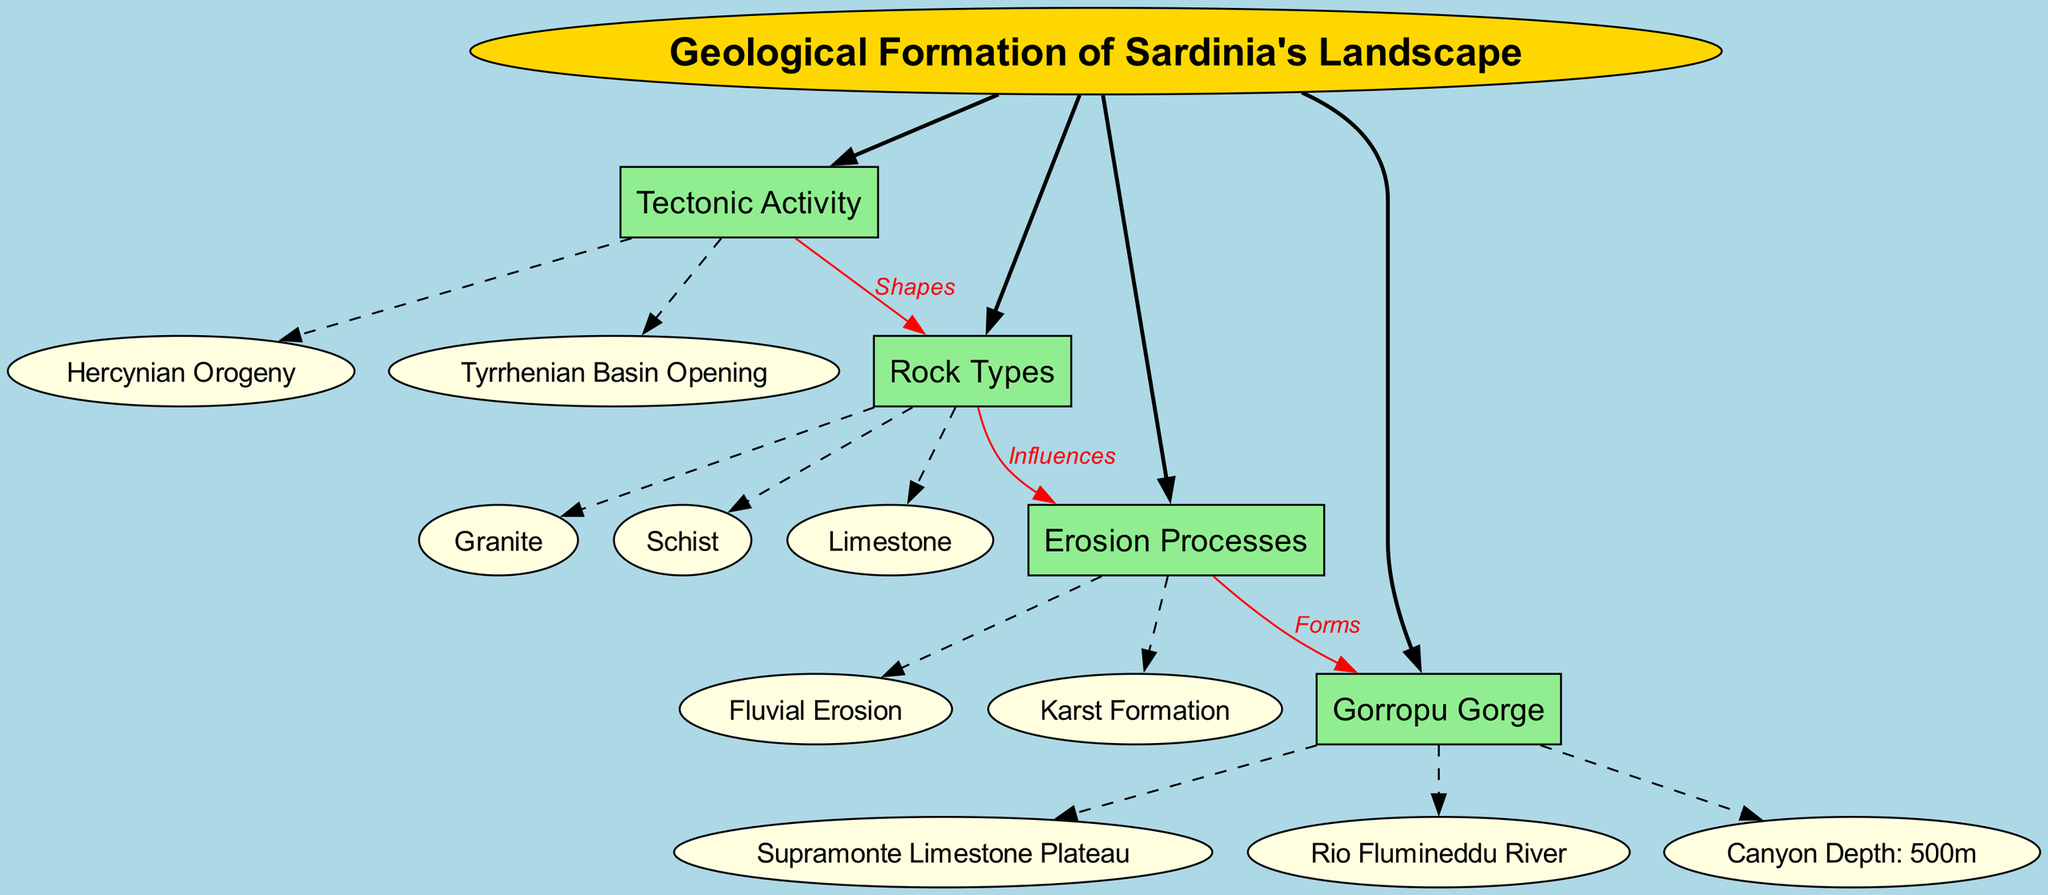What are the main branches in the diagram? The main branches listed in the diagram are Tectonic Activity, Rock Types, Erosion Processes, and Gorropu Gorge.
Answer: Tectonic Activity, Rock Types, Erosion Processes, Gorropu Gorge What influences the Erosion Processes? The diagram indicates a direct relationship between Rock Types and Erosion Processes, where Rock Types influence the Erosion Processes.
Answer: Rock Types What is the depth of the Gorropu Gorge? The diagram specifies that the Canyon Depth is 500m, which indicates the depth of the Gorropu Gorge.
Answer: 500m What geological event shapes the Rock Types? According to the diagram, the Tectonic Activity is responsible for shaping the Rock Types in Sardinia's landscape.
Answer: Tectonic Activity Which rock type is associated with the Gorropu Gorge? The Gorropu Gorge is associated with the Supramonte Limestone Plateau, reflecting the type of rocks involved in that area of the landscape.
Answer: Supramonte Limestone How many sub-branches does the branch "Erosion Processes" have? The Erosion Processes branch contains two sub-branches: Fluvial Erosion and Karst Formation. Therefore, it has two sub-branches.
Answer: 2 What forms the Gorropu Gorge according to the diagram? The diagram states that Erosion Processes specifically form the Gorropu Gorge, illustrating the link between erosion and canyon formation.
Answer: Erosion Processes Which process is directly linked to Fluvial Erosion? The diagram shows that Rock Types influence Erosion Processes, thereby linking Fluvial Erosion to the types of rocks present in Sardinia's landscape.
Answer: Rock Types 